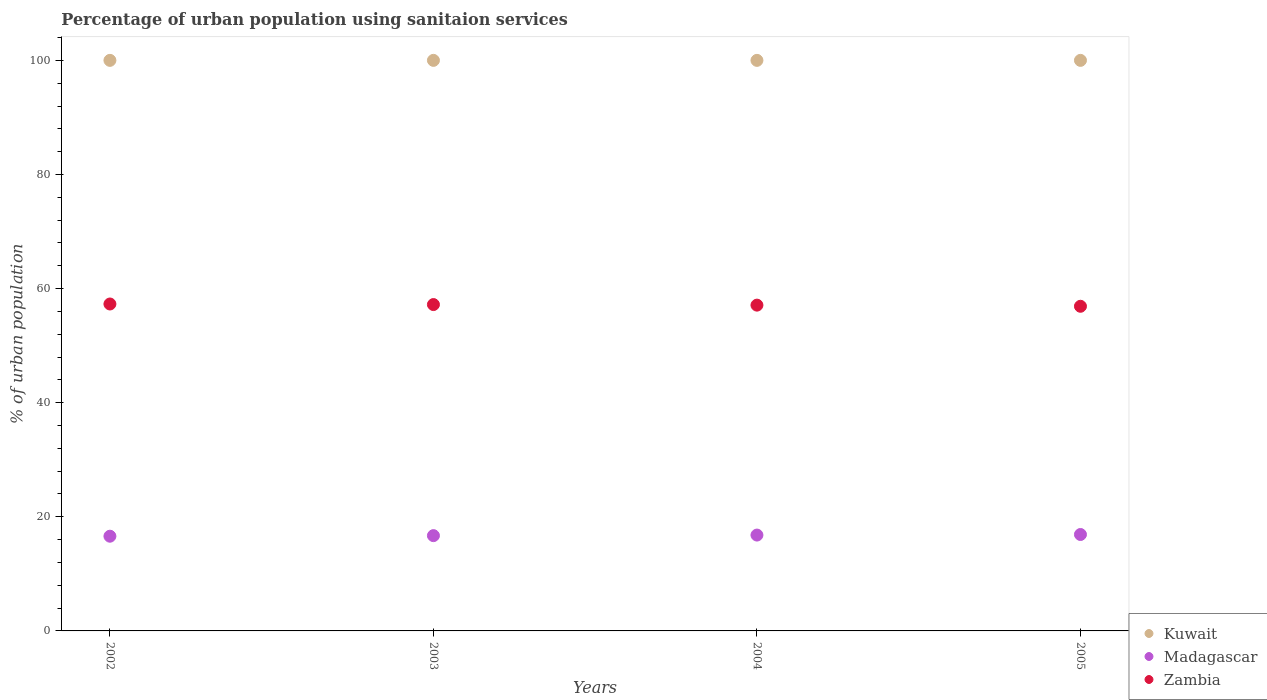How many different coloured dotlines are there?
Make the answer very short. 3. Is the number of dotlines equal to the number of legend labels?
Make the answer very short. Yes. Across all years, what is the maximum percentage of urban population using sanitaion services in Kuwait?
Make the answer very short. 100. Across all years, what is the minimum percentage of urban population using sanitaion services in Kuwait?
Make the answer very short. 100. In which year was the percentage of urban population using sanitaion services in Kuwait maximum?
Your response must be concise. 2002. In which year was the percentage of urban population using sanitaion services in Madagascar minimum?
Provide a short and direct response. 2002. What is the difference between the percentage of urban population using sanitaion services in Madagascar in 2002 and that in 2005?
Give a very brief answer. -0.3. What is the difference between the percentage of urban population using sanitaion services in Kuwait in 2002 and the percentage of urban population using sanitaion services in Zambia in 2003?
Provide a succinct answer. 42.8. What is the ratio of the percentage of urban population using sanitaion services in Madagascar in 2002 to that in 2005?
Give a very brief answer. 0.98. What is the difference between the highest and the second highest percentage of urban population using sanitaion services in Zambia?
Your response must be concise. 0.1. Is the percentage of urban population using sanitaion services in Kuwait strictly greater than the percentage of urban population using sanitaion services in Zambia over the years?
Your answer should be compact. Yes. How many years are there in the graph?
Your answer should be compact. 4. Does the graph contain grids?
Give a very brief answer. No. Where does the legend appear in the graph?
Provide a succinct answer. Bottom right. How many legend labels are there?
Offer a very short reply. 3. How are the legend labels stacked?
Your response must be concise. Vertical. What is the title of the graph?
Offer a very short reply. Percentage of urban population using sanitaion services. What is the label or title of the Y-axis?
Provide a succinct answer. % of urban population. What is the % of urban population of Zambia in 2002?
Offer a terse response. 57.3. What is the % of urban population of Kuwait in 2003?
Offer a very short reply. 100. What is the % of urban population in Zambia in 2003?
Offer a very short reply. 57.2. What is the % of urban population of Kuwait in 2004?
Your response must be concise. 100. What is the % of urban population of Madagascar in 2004?
Provide a succinct answer. 16.8. What is the % of urban population in Zambia in 2004?
Ensure brevity in your answer.  57.1. What is the % of urban population in Madagascar in 2005?
Your answer should be compact. 16.9. What is the % of urban population in Zambia in 2005?
Give a very brief answer. 56.9. Across all years, what is the maximum % of urban population of Kuwait?
Ensure brevity in your answer.  100. Across all years, what is the maximum % of urban population of Zambia?
Offer a terse response. 57.3. Across all years, what is the minimum % of urban population of Zambia?
Provide a short and direct response. 56.9. What is the total % of urban population of Kuwait in the graph?
Offer a terse response. 400. What is the total % of urban population of Madagascar in the graph?
Your answer should be compact. 67. What is the total % of urban population of Zambia in the graph?
Your answer should be compact. 228.5. What is the difference between the % of urban population in Zambia in 2002 and that in 2003?
Ensure brevity in your answer.  0.1. What is the difference between the % of urban population of Kuwait in 2002 and that in 2004?
Give a very brief answer. 0. What is the difference between the % of urban population of Zambia in 2002 and that in 2004?
Provide a short and direct response. 0.2. What is the difference between the % of urban population in Zambia in 2002 and that in 2005?
Your response must be concise. 0.4. What is the difference between the % of urban population in Kuwait in 2003 and that in 2005?
Give a very brief answer. 0. What is the difference between the % of urban population of Zambia in 2003 and that in 2005?
Keep it short and to the point. 0.3. What is the difference between the % of urban population in Kuwait in 2004 and that in 2005?
Provide a succinct answer. 0. What is the difference between the % of urban population in Madagascar in 2004 and that in 2005?
Ensure brevity in your answer.  -0.1. What is the difference between the % of urban population of Kuwait in 2002 and the % of urban population of Madagascar in 2003?
Make the answer very short. 83.3. What is the difference between the % of urban population of Kuwait in 2002 and the % of urban population of Zambia in 2003?
Ensure brevity in your answer.  42.8. What is the difference between the % of urban population of Madagascar in 2002 and the % of urban population of Zambia in 2003?
Keep it short and to the point. -40.6. What is the difference between the % of urban population in Kuwait in 2002 and the % of urban population in Madagascar in 2004?
Provide a short and direct response. 83.2. What is the difference between the % of urban population of Kuwait in 2002 and the % of urban population of Zambia in 2004?
Provide a succinct answer. 42.9. What is the difference between the % of urban population of Madagascar in 2002 and the % of urban population of Zambia in 2004?
Offer a terse response. -40.5. What is the difference between the % of urban population in Kuwait in 2002 and the % of urban population in Madagascar in 2005?
Provide a short and direct response. 83.1. What is the difference between the % of urban population in Kuwait in 2002 and the % of urban population in Zambia in 2005?
Make the answer very short. 43.1. What is the difference between the % of urban population of Madagascar in 2002 and the % of urban population of Zambia in 2005?
Give a very brief answer. -40.3. What is the difference between the % of urban population in Kuwait in 2003 and the % of urban population in Madagascar in 2004?
Your answer should be compact. 83.2. What is the difference between the % of urban population in Kuwait in 2003 and the % of urban population in Zambia in 2004?
Give a very brief answer. 42.9. What is the difference between the % of urban population in Madagascar in 2003 and the % of urban population in Zambia in 2004?
Your answer should be very brief. -40.4. What is the difference between the % of urban population in Kuwait in 2003 and the % of urban population in Madagascar in 2005?
Make the answer very short. 83.1. What is the difference between the % of urban population of Kuwait in 2003 and the % of urban population of Zambia in 2005?
Offer a terse response. 43.1. What is the difference between the % of urban population of Madagascar in 2003 and the % of urban population of Zambia in 2005?
Offer a terse response. -40.2. What is the difference between the % of urban population in Kuwait in 2004 and the % of urban population in Madagascar in 2005?
Provide a succinct answer. 83.1. What is the difference between the % of urban population in Kuwait in 2004 and the % of urban population in Zambia in 2005?
Provide a succinct answer. 43.1. What is the difference between the % of urban population in Madagascar in 2004 and the % of urban population in Zambia in 2005?
Your answer should be very brief. -40.1. What is the average % of urban population in Madagascar per year?
Keep it short and to the point. 16.75. What is the average % of urban population of Zambia per year?
Ensure brevity in your answer.  57.12. In the year 2002, what is the difference between the % of urban population of Kuwait and % of urban population of Madagascar?
Ensure brevity in your answer.  83.4. In the year 2002, what is the difference between the % of urban population in Kuwait and % of urban population in Zambia?
Your answer should be compact. 42.7. In the year 2002, what is the difference between the % of urban population of Madagascar and % of urban population of Zambia?
Keep it short and to the point. -40.7. In the year 2003, what is the difference between the % of urban population in Kuwait and % of urban population in Madagascar?
Provide a short and direct response. 83.3. In the year 2003, what is the difference between the % of urban population of Kuwait and % of urban population of Zambia?
Your response must be concise. 42.8. In the year 2003, what is the difference between the % of urban population in Madagascar and % of urban population in Zambia?
Offer a terse response. -40.5. In the year 2004, what is the difference between the % of urban population in Kuwait and % of urban population in Madagascar?
Ensure brevity in your answer.  83.2. In the year 2004, what is the difference between the % of urban population of Kuwait and % of urban population of Zambia?
Offer a terse response. 42.9. In the year 2004, what is the difference between the % of urban population in Madagascar and % of urban population in Zambia?
Your response must be concise. -40.3. In the year 2005, what is the difference between the % of urban population in Kuwait and % of urban population in Madagascar?
Offer a very short reply. 83.1. In the year 2005, what is the difference between the % of urban population in Kuwait and % of urban population in Zambia?
Your answer should be compact. 43.1. In the year 2005, what is the difference between the % of urban population of Madagascar and % of urban population of Zambia?
Provide a short and direct response. -40. What is the ratio of the % of urban population of Kuwait in 2002 to that in 2003?
Provide a succinct answer. 1. What is the ratio of the % of urban population in Madagascar in 2002 to that in 2003?
Your answer should be compact. 0.99. What is the ratio of the % of urban population of Zambia in 2002 to that in 2003?
Give a very brief answer. 1. What is the ratio of the % of urban population in Kuwait in 2002 to that in 2004?
Provide a succinct answer. 1. What is the ratio of the % of urban population in Madagascar in 2002 to that in 2004?
Your answer should be compact. 0.99. What is the ratio of the % of urban population in Zambia in 2002 to that in 2004?
Your answer should be compact. 1. What is the ratio of the % of urban population in Madagascar in 2002 to that in 2005?
Ensure brevity in your answer.  0.98. What is the ratio of the % of urban population of Zambia in 2002 to that in 2005?
Your answer should be very brief. 1.01. What is the ratio of the % of urban population in Zambia in 2003 to that in 2004?
Your answer should be compact. 1. What is the ratio of the % of urban population in Kuwait in 2003 to that in 2005?
Provide a short and direct response. 1. What is the ratio of the % of urban population in Madagascar in 2003 to that in 2005?
Provide a short and direct response. 0.99. What is the ratio of the % of urban population of Zambia in 2004 to that in 2005?
Make the answer very short. 1. What is the difference between the highest and the second highest % of urban population in Madagascar?
Your answer should be very brief. 0.1. What is the difference between the highest and the lowest % of urban population of Kuwait?
Your answer should be very brief. 0. What is the difference between the highest and the lowest % of urban population in Zambia?
Give a very brief answer. 0.4. 